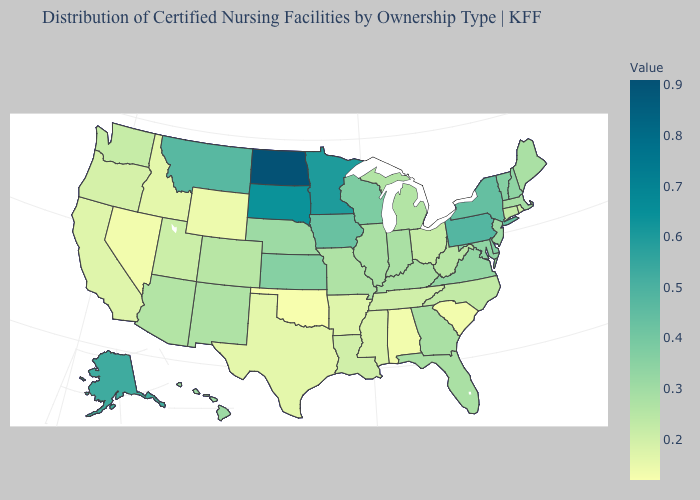Which states have the lowest value in the USA?
Concise answer only. Oklahoma. Does Nevada have the lowest value in the West?
Concise answer only. Yes. Does Alaska have the lowest value in the West?
Give a very brief answer. No. Does Ohio have the lowest value in the MidWest?
Short answer required. Yes. 